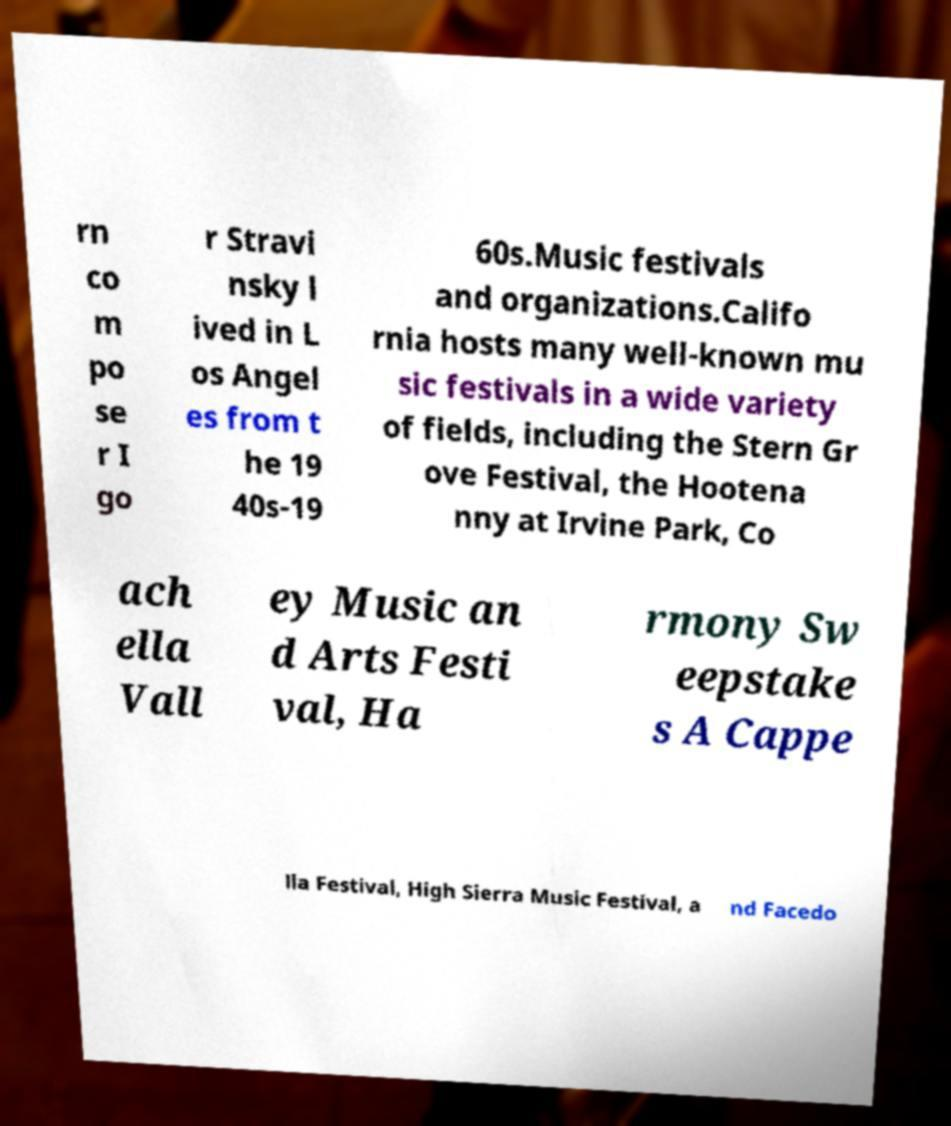Can you accurately transcribe the text from the provided image for me? rn co m po se r I go r Stravi nsky l ived in L os Angel es from t he 19 40s-19 60s.Music festivals and organizations.Califo rnia hosts many well-known mu sic festivals in a wide variety of fields, including the Stern Gr ove Festival, the Hootena nny at Irvine Park, Co ach ella Vall ey Music an d Arts Festi val, Ha rmony Sw eepstake s A Cappe lla Festival, High Sierra Music Festival, a nd Facedo 